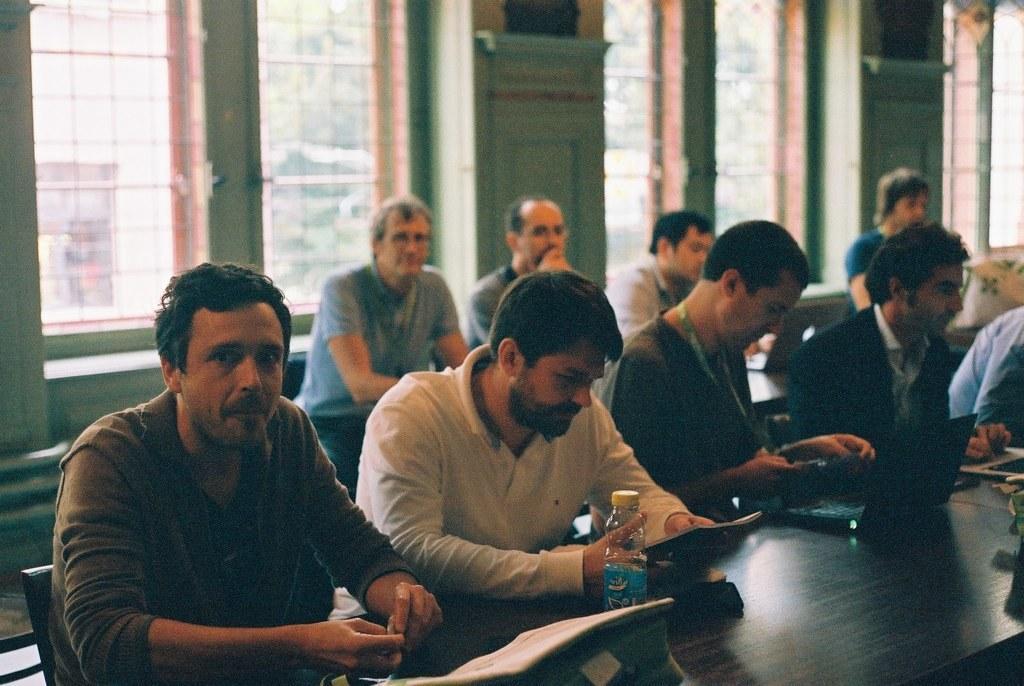Describe this image in one or two sentences. In this given picture, I can see a group of people holding a cell phone and behind this group of people, I can see windows and a white color bag towards right and i can see few objects which includes with water bottle. 